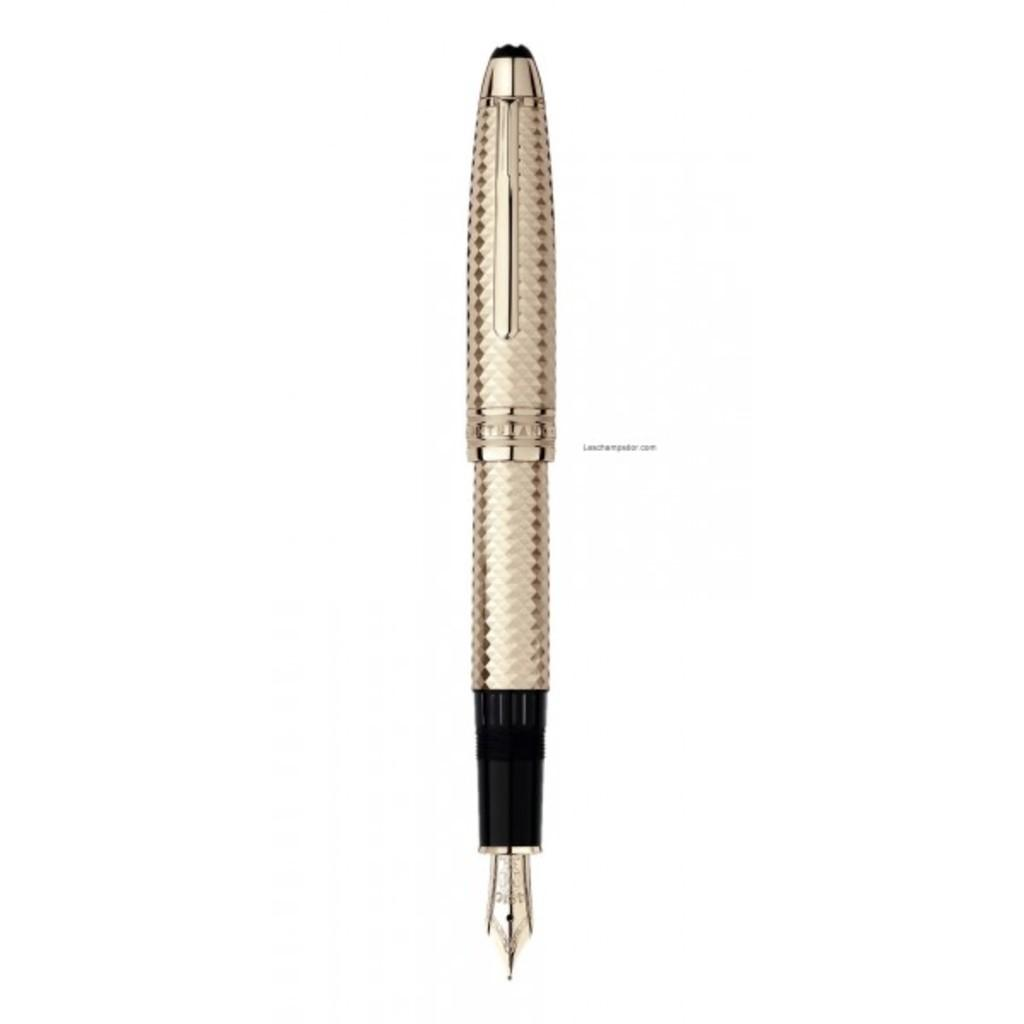What type of writing instrument is in the image? There is a golden color ink pen in the image. What is the shape of the nib on the ink pen? The ink pen has a pointed nib. What color is the background of the image? The background of the image is white. What type of linen is used to cover the ink pen in the image? There is no linen present in the image, and the ink pen is not covered. 